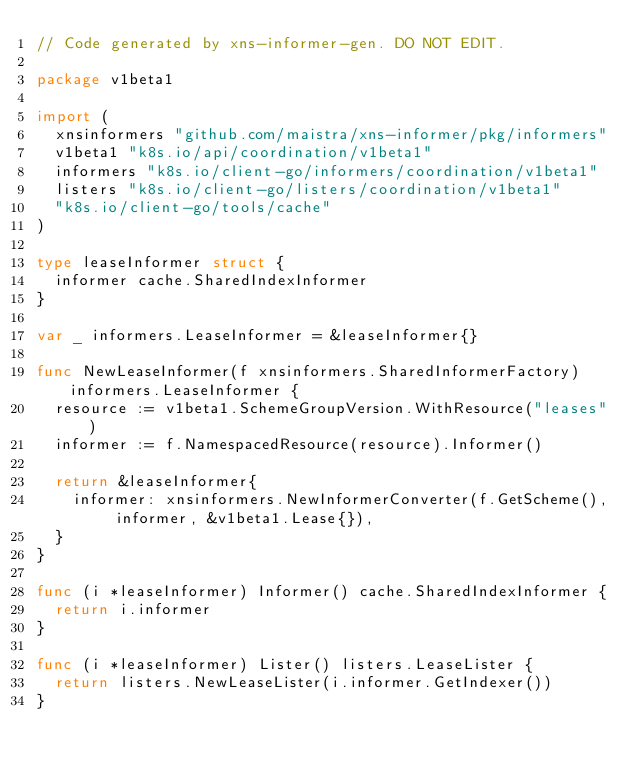<code> <loc_0><loc_0><loc_500><loc_500><_Go_>// Code generated by xns-informer-gen. DO NOT EDIT.

package v1beta1

import (
	xnsinformers "github.com/maistra/xns-informer/pkg/informers"
	v1beta1 "k8s.io/api/coordination/v1beta1"
	informers "k8s.io/client-go/informers/coordination/v1beta1"
	listers "k8s.io/client-go/listers/coordination/v1beta1"
	"k8s.io/client-go/tools/cache"
)

type leaseInformer struct {
	informer cache.SharedIndexInformer
}

var _ informers.LeaseInformer = &leaseInformer{}

func NewLeaseInformer(f xnsinformers.SharedInformerFactory) informers.LeaseInformer {
	resource := v1beta1.SchemeGroupVersion.WithResource("leases")
	informer := f.NamespacedResource(resource).Informer()

	return &leaseInformer{
		informer: xnsinformers.NewInformerConverter(f.GetScheme(), informer, &v1beta1.Lease{}),
	}
}

func (i *leaseInformer) Informer() cache.SharedIndexInformer {
	return i.informer
}

func (i *leaseInformer) Lister() listers.LeaseLister {
	return listers.NewLeaseLister(i.informer.GetIndexer())
}
</code> 